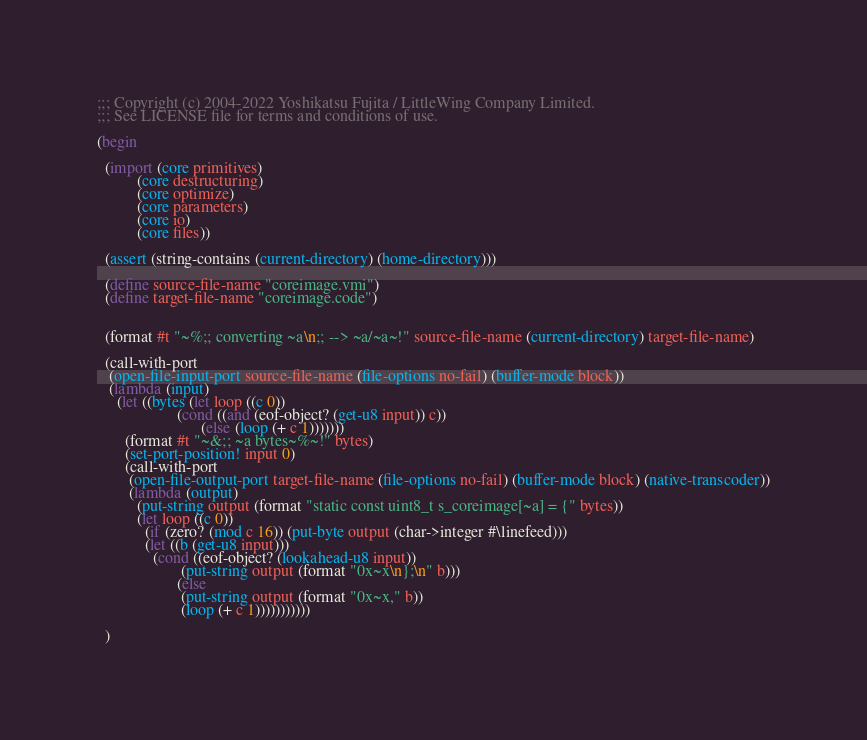Convert code to text. <code><loc_0><loc_0><loc_500><loc_500><_Scheme_>;;; Copyright (c) 2004-2022 Yoshikatsu Fujita / LittleWing Company Limited.
;;; See LICENSE file for terms and conditions of use.

(begin

  (import (core primitives)
          (core destructuring)
          (core optimize)
          (core parameters)
          (core io)
          (core files))

  (assert (string-contains (current-directory) (home-directory)))

  (define source-file-name "coreimage.vmi")
  (define target-file-name "coreimage.code")


  (format #t "~%;; converting ~a\n;; --> ~a/~a~!" source-file-name (current-directory) target-file-name)

  (call-with-port
   (open-file-input-port source-file-name (file-options no-fail) (buffer-mode block))
   (lambda (input)
     (let ((bytes (let loop ((c 0))
                    (cond ((and (eof-object? (get-u8 input)) c))
                          (else (loop (+ c 1)))))))
       (format #t "~&;; ~a bytes~%~!" bytes)
       (set-port-position! input 0)
       (call-with-port
        (open-file-output-port target-file-name (file-options no-fail) (buffer-mode block) (native-transcoder))
        (lambda (output)
          (put-string output (format "static const uint8_t s_coreimage[~a] = {" bytes))
          (let loop ((c 0))
            (if (zero? (mod c 16)) (put-byte output (char->integer #\linefeed)))
            (let ((b (get-u8 input)))
              (cond ((eof-object? (lookahead-u8 input))
                     (put-string output (format "0x~x\n};\n" b)))
                    (else
                     (put-string output (format "0x~x," b))
                     (loop (+ c 1)))))))))))

  )
</code> 